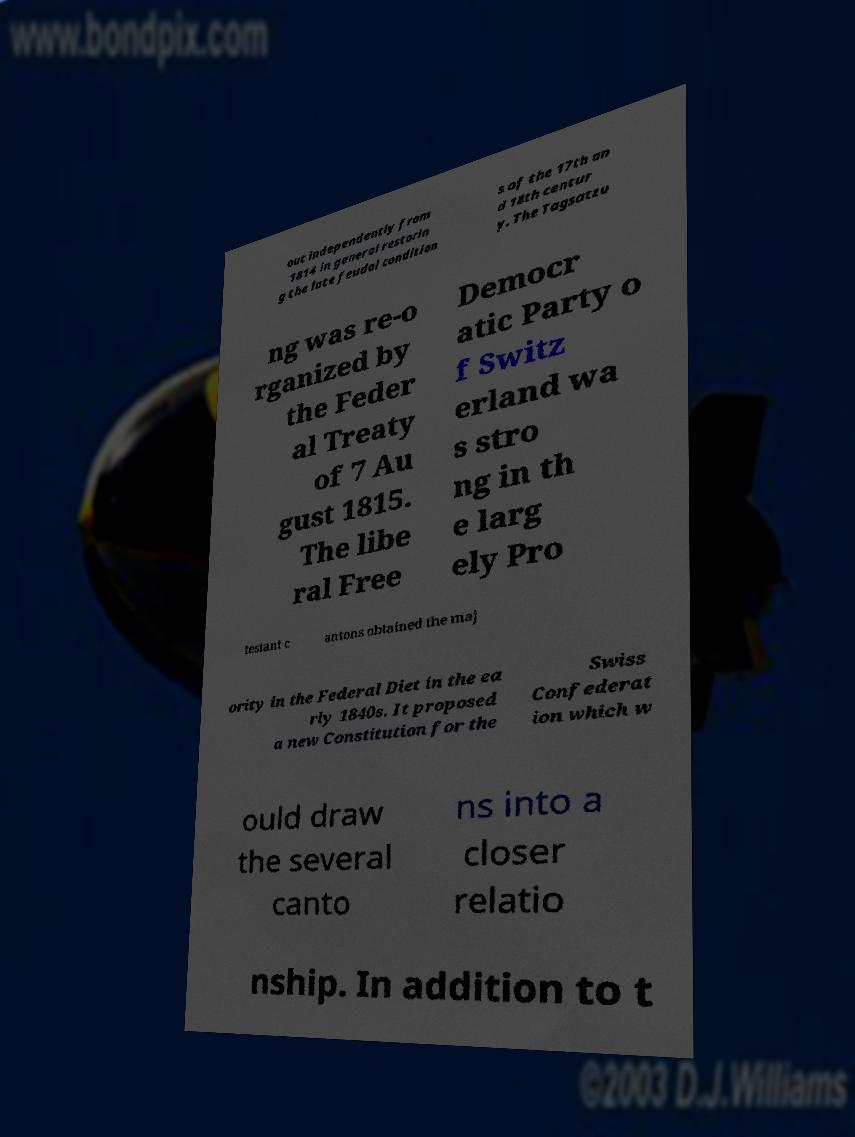Could you extract and type out the text from this image? out independently from 1814 in general restorin g the late feudal condition s of the 17th an d 18th centur y. The Tagsatzu ng was re-o rganized by the Feder al Treaty of 7 Au gust 1815. The libe ral Free Democr atic Party o f Switz erland wa s stro ng in th e larg ely Pro testant c antons obtained the maj ority in the Federal Diet in the ea rly 1840s. It proposed a new Constitution for the Swiss Confederat ion which w ould draw the several canto ns into a closer relatio nship. In addition to t 